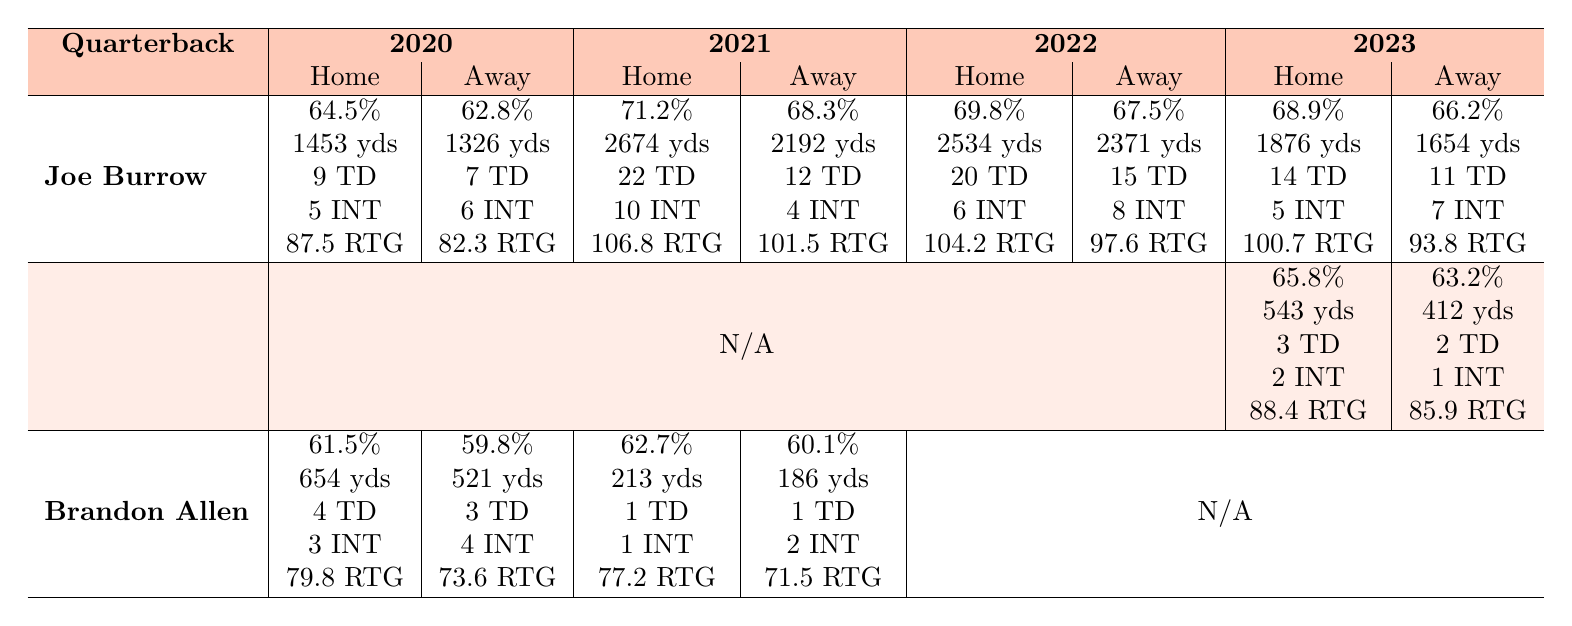What was Joe Burrow's highest completion percentage in home games? In the data, Joe Burrow's completion percentage in home games is provided for each season. The highest value is from 2021, which is 71.2%.
Answer: 71.2% How many touchdowns did Brandon Allen throw in away games during the 2021 season? The table shows that Brandon Allen threw 1 touchdown in away games during the 2021 season.
Answer: 1 What is the difference in passer rating for Joe Burrow in home vs. away games for the 2022 season? Joe Burrow's passer rating for home games in 2022 is 104.2, and for away games, it is 97.6. The difference is calculated as 104.2 - 97.6 = 6.6.
Answer: 6.6 Did Jake Browning achieve a higher completion percentage away or at home in 2023? Jake Browning's completion percentage at home in 2023 is 65.8%, while away it is 63.2%. This indicates he performed better at home.
Answer: Yes What is the average number of interceptions thrown by Joe Burrow across all seasons in home games? Joe Burrow's interceptions in home games for the seasons are: 5 (2020), 10 (2021), 6 (2022), and 5 (2023). Summing these gives 5 + 10 + 6 + 5 = 26. The average is 26/4 = 6.5.
Answer: 6.5 Which quarterback had the highest total passing yards in home games across all available seasons? Examining the total home passing yards: Joe Burrow had the highest in 2021 with 2674 yards. No other quarterback exceeds that in home games.
Answer: Joe Burrow What was Brandon Allen's total number of touchdowns thrown in away games across 2020 and 2021? Brandon Allen threw 3 touchdowns in away games in 2020 and 1 touchdown in 2021. Summing these gives 3 + 1 = 4 touchdowns total.
Answer: 4 For which season did Joe Burrow have the lowest passer rating in away games? Looking at the away game passer ratings for Burrow, the lowest was in 2023 at 93.8.
Answer: 2023 What is the completion percentage difference for Jake Browning between home and away games in 2023? Jake Browning's completion percentage in home games is 65.8%, and in away games, it's 63.2%. The difference is 65.8 - 63.2 = 2.6.
Answer: 2.6 Did any quarterback have a lower completion percentage in away games compared to home games in the 2020 season? For 2020, Joe Burrow had 62.8% away compared to 64.5% at home, and Brandon Allen had 59.8% away compared to 61.5% at home. Both had lower away percentages.
Answer: Yes 